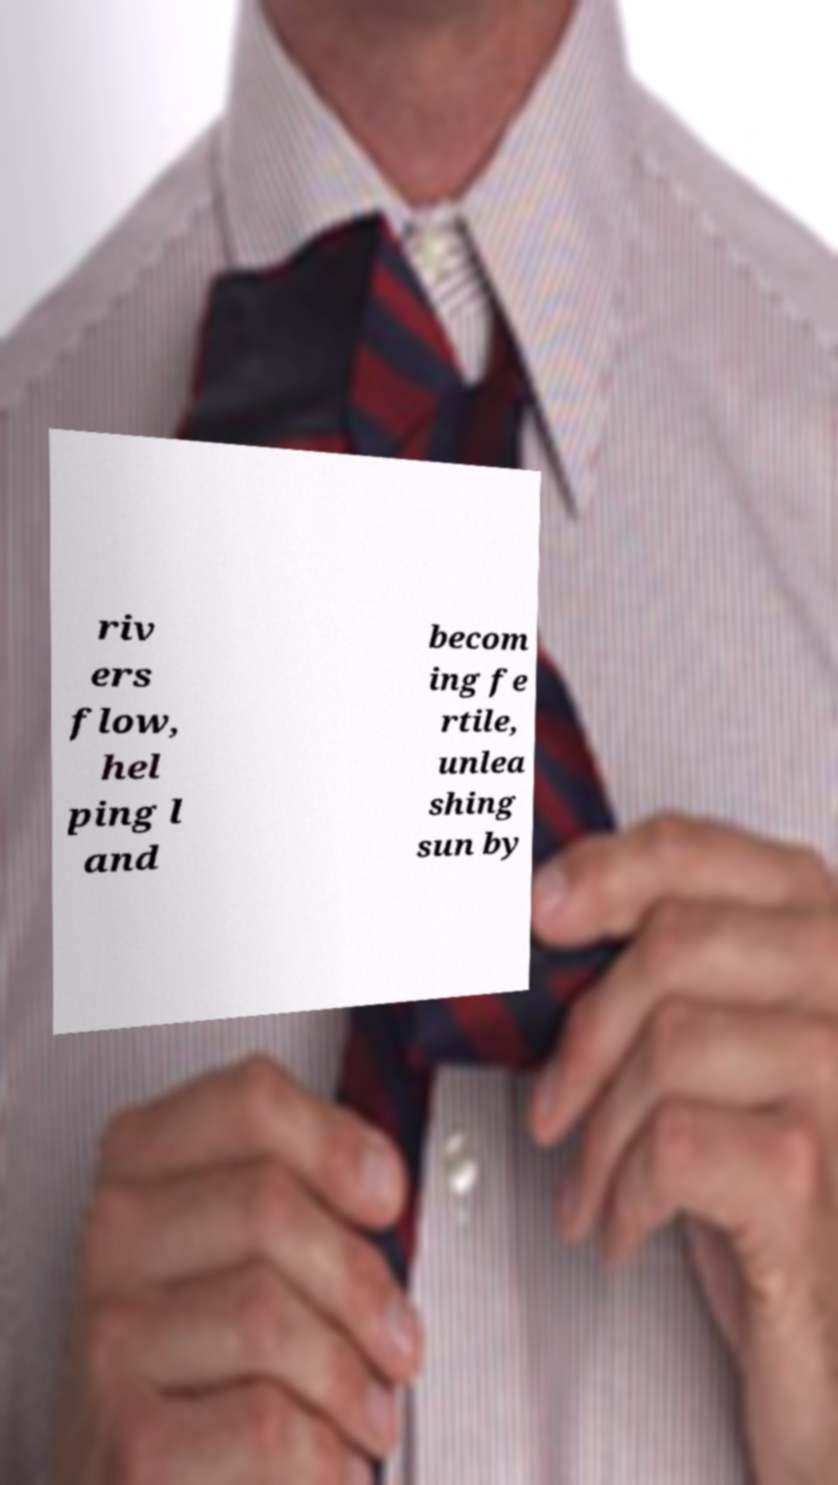Can you read and provide the text displayed in the image?This photo seems to have some interesting text. Can you extract and type it out for me? riv ers flow, hel ping l and becom ing fe rtile, unlea shing sun by 